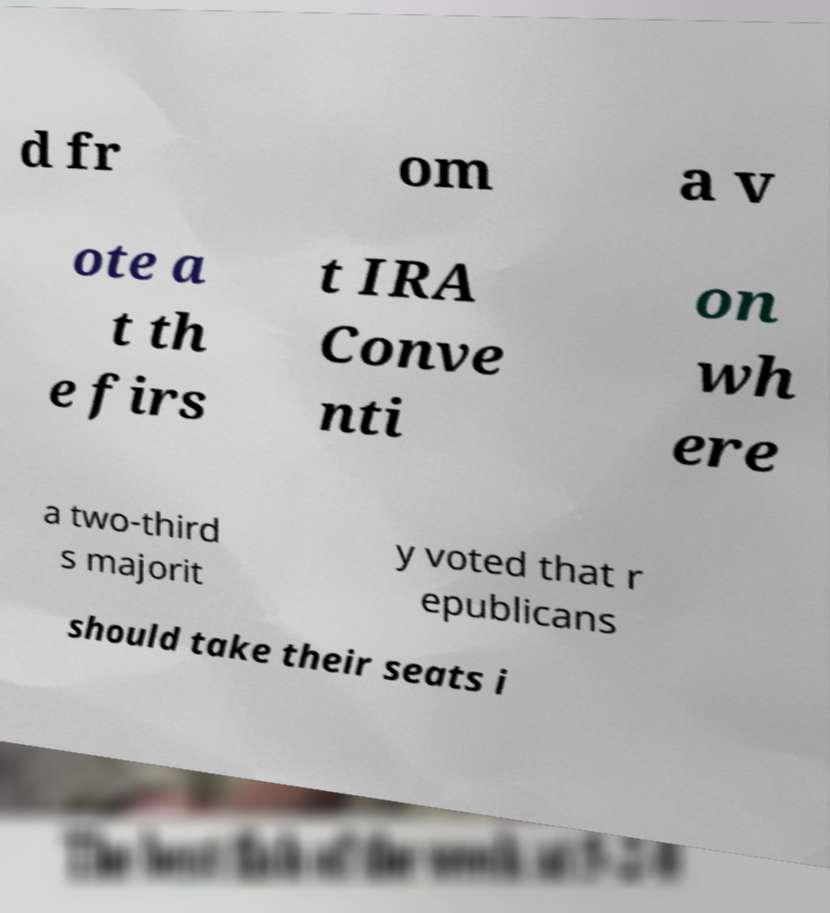Could you extract and type out the text from this image? d fr om a v ote a t th e firs t IRA Conve nti on wh ere a two-third s majorit y voted that r epublicans should take their seats i 